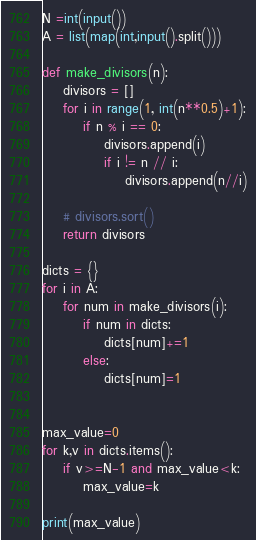Convert code to text. <code><loc_0><loc_0><loc_500><loc_500><_Python_>N =int(input())
A = list(map(int,input().split()))

def make_divisors(n):
    divisors = []
    for i in range(1, int(n**0.5)+1):
        if n % i == 0:
            divisors.append(i)
            if i != n // i:
                divisors.append(n//i)

    # divisors.sort()
    return divisors

dicts = {}
for i in A:
    for num in make_divisors(i):
        if num in dicts:
            dicts[num]+=1
        else:
            dicts[num]=1


max_value=0
for k,v in dicts.items():
    if v>=N-1 and max_value<k:
        max_value=k

print(max_value)</code> 